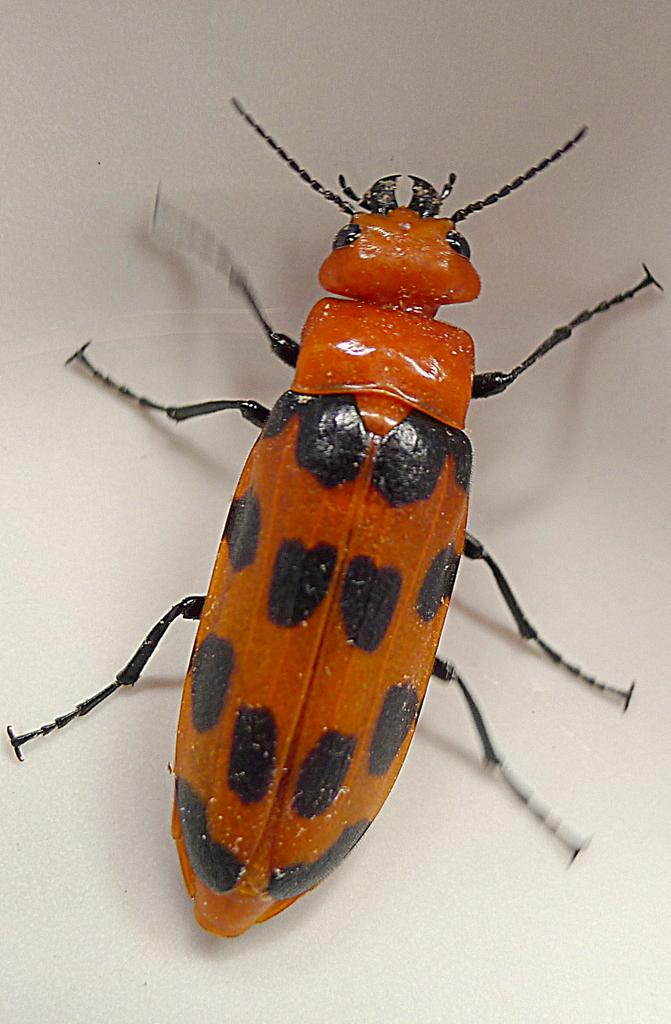What type of creature can be seen in the image? There is an insect in the image. What time of day is depicted in the image? The time of day cannot be determined from the image, as there is no reference to time or any objects that might indicate the time of day. 